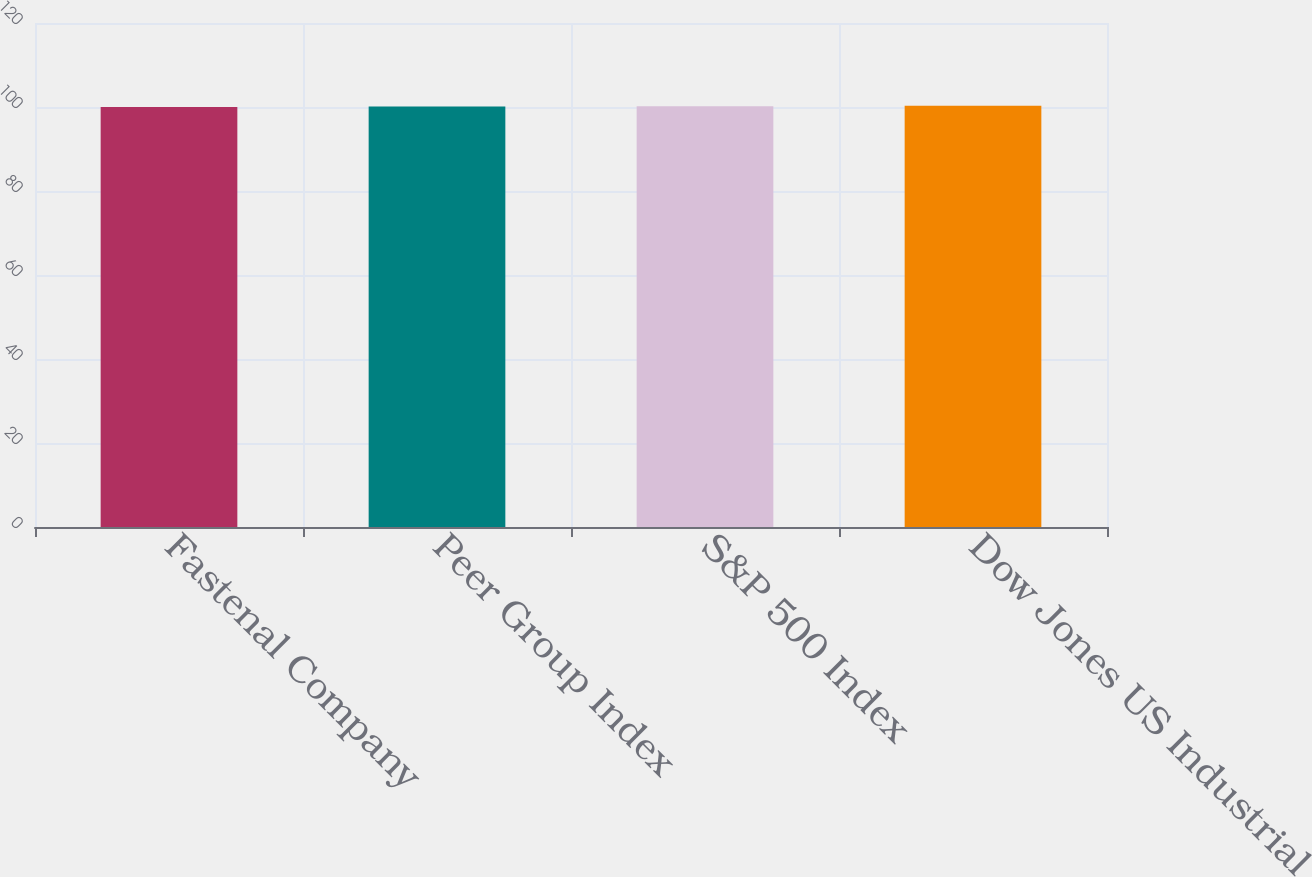Convert chart to OTSL. <chart><loc_0><loc_0><loc_500><loc_500><bar_chart><fcel>Fastenal Company<fcel>Peer Group Index<fcel>S&P 500 Index<fcel>Dow Jones US Industrial<nl><fcel>100<fcel>100.1<fcel>100.2<fcel>100.3<nl></chart> 